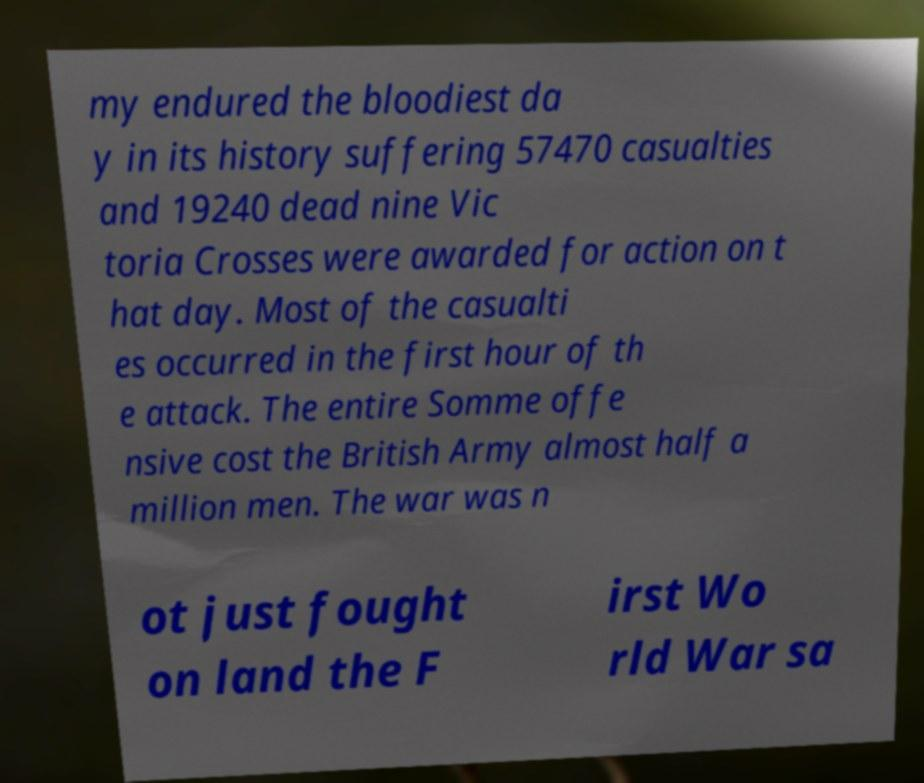Could you extract and type out the text from this image? my endured the bloodiest da y in its history suffering 57470 casualties and 19240 dead nine Vic toria Crosses were awarded for action on t hat day. Most of the casualti es occurred in the first hour of th e attack. The entire Somme offe nsive cost the British Army almost half a million men. The war was n ot just fought on land the F irst Wo rld War sa 